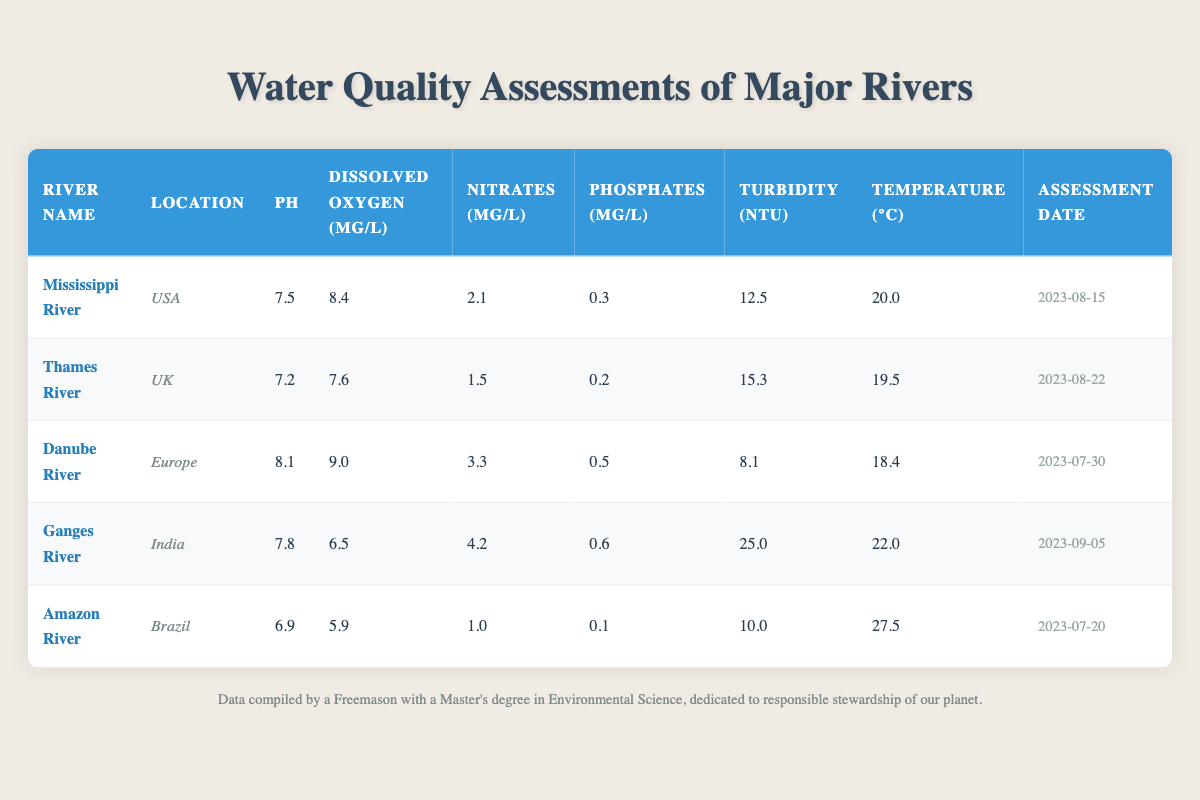What is the pH of the Amazon River? The pH level is listed in the table under the "pH" column for the Amazon River row, which shows a value of 6.9.
Answer: 6.9 Which river has the highest level of dissolved oxygen? The levels of dissolved oxygen are listed in the "Dissolved Oxygen (mg/L)" column. The values are 8.4 for the Mississippi River, 7.6 for the Thames River, 9.0 for the Danube River, 6.5 for the Ganges River, and 5.9 for the Amazon River. The highest value is 9.0 for the Danube River.
Answer: Danube River What is the average turbidity of all the rivers assessed? The turbidity values are 12.5, 15.3, 8.1, 25.0, and 10.0 NTU. To find the average, sum these values: 12.5 + 15.3 + 8.1 + 25.0 + 10.0 = 70.9. There are 5 data points, so the average is 70.9 / 5 = 14.18.
Answer: 14.18 Is the level of nitrates in the Ganges River greater than in the Amazon River? The nitrate levels are 4.2 mg/L for the Ganges River and 1.0 mg/L for the Amazon River. Since 4.2 is greater than 1.0, the statement is true.
Answer: Yes Which river has the lowest pH and what is its value? The pH values listed are 7.5 for the Mississippi, 7.2 for the Thames, 8.1 for the Danube, 7.8 for the Ganges, and 6.9 for the Amazon. Comparing these, 6.9 is the lowest, which applies to the Amazon River.
Answer: 6.9 What is the difference in dissolved oxygen between the Danube River and the Ganges River? The dissolved oxygen is 9.0 mg/L for the Danube River and 6.5 mg/L for the Ganges River. The difference is calculated as 9.0 - 6.5 = 2.5 mg/L.
Answer: 2.5 mg/L Which river had the water quality assessment done latest and what is the assessment date? The Ganges River has an assessment date of 2023-09-05, which is the most recent date compared to the other rivers listed.
Answer: 2023-09-05 Is the turbidity of the Thames River higher than that of the Amazon River? The turbidity levels are 15.3 NTU for the Thames River and 10.0 NTU for the Amazon River. Since 15.3 is greater, the claim is true.
Answer: Yes 